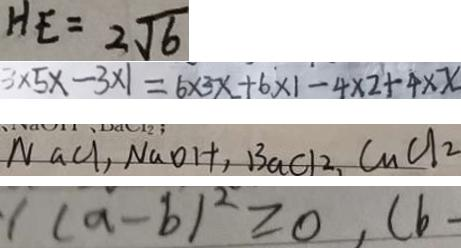<formula> <loc_0><loc_0><loc_500><loc_500>H E = 2 \sqrt { 6 } 
 3 \times 5 x - 3 \times 1 = 6 \times 3 x + 6 \times 1 - 4 \times 2 + 4 \times x 
 N a C l , N a O H , B a C l _ { 2 } , C u C l _ { 2 } 
 1 ( a - b ) ^ { 2 } \geq 0 , ( b</formula> 